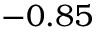<formula> <loc_0><loc_0><loc_500><loc_500>- 0 . 8 5</formula> 